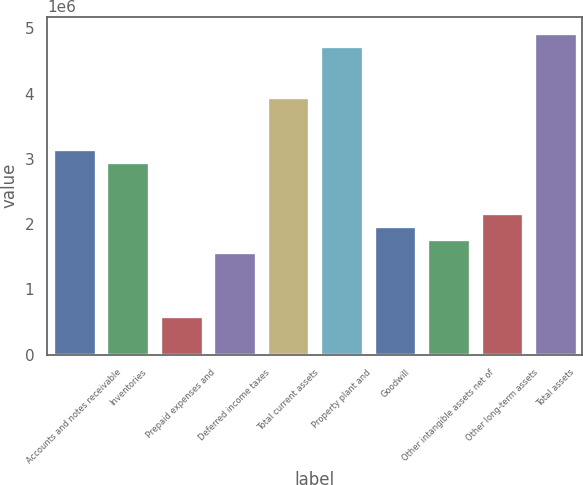Convert chart to OTSL. <chart><loc_0><loc_0><loc_500><loc_500><bar_chart><fcel>Accounts and notes receivable<fcel>Inventories<fcel>Prepaid expenses and<fcel>Deferred income taxes<fcel>Total current assets<fcel>Property plant and<fcel>Goodwill<fcel>Other intangible assets net of<fcel>Other long-term assets<fcel>Total assets<nl><fcel>3.15727e+06<fcel>2.95994e+06<fcel>591992<fcel>1.57864e+06<fcel>3.94659e+06<fcel>4.73591e+06<fcel>1.9733e+06<fcel>1.77597e+06<fcel>2.17063e+06<fcel>4.93324e+06<nl></chart> 